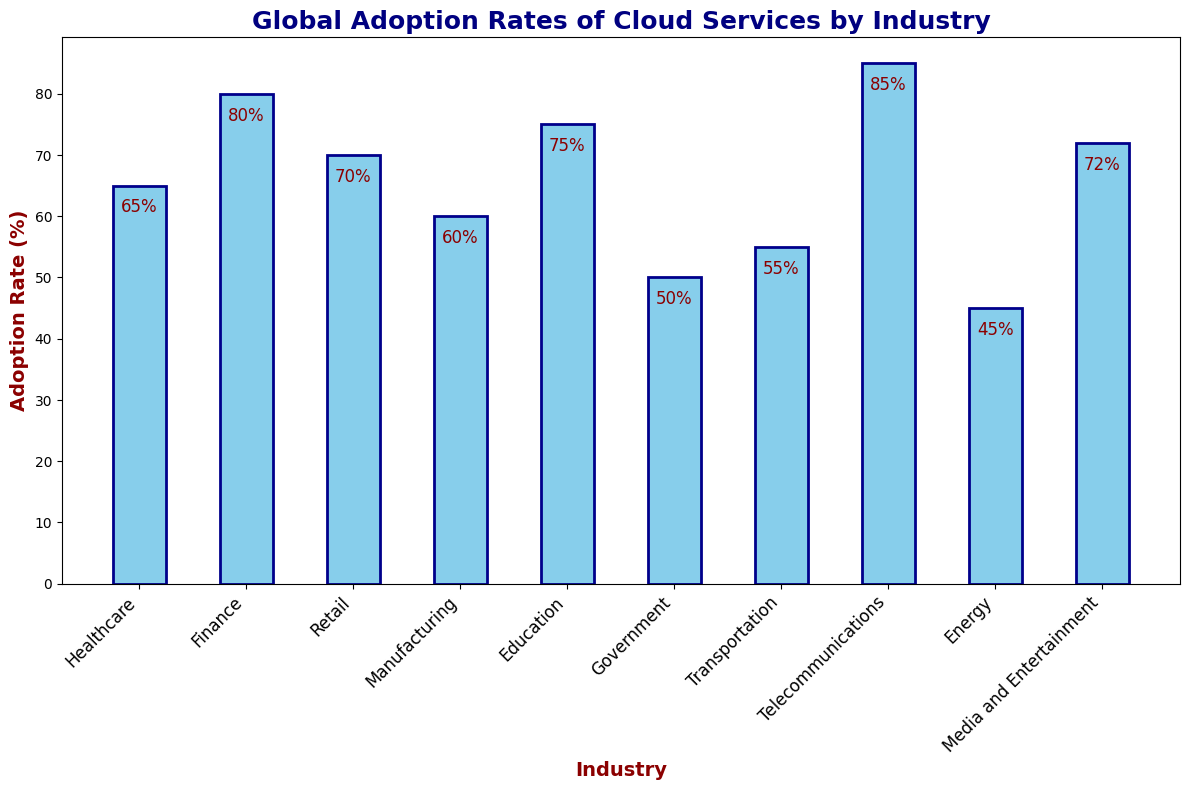Which industry has the highest adoption rate of cloud services? To find the industry with the highest adoption rate, look at the top of the tallest bar. The tallest bar represents the Telecommunications industry with an 85% adoption rate.
Answer: Telecommunications Which industry has a lower adoption rate, Government or Transportation? Compare the heights of the bars for Government and Transportation. Government has a 50% adoption rate, while Transportation has a 55% adoption rate. Therefore, the Government industry has a lower adoption rate.
Answer: Government What is the difference in cloud service adoption rates between Healthcare and Retail? The bar for Healthcare rests at 65% and the bar for Retail at 70%. Subtract the lower adoption rate (Healthcare) from the higher adoption rate (Retail): 70% - 65% = 5%.
Answer: 5% What is the combined adoption rate for Finance and Media and Entertainment? Find the adoption rates for Finance (80%) and Media and Entertainment (72%). Add these rates together: 80% + 72% = 152%.
Answer: 152% Which industry has the second-lowest adoption rate of cloud services? Identify the second shortest bar in the chart, which is the Energy industry with a 45% adoption rate (the shortest is Government with 50%).
Answer: Energy How many industries have an adoption rate above 70%? Count the bars with heights above the 70% mark: Finance (80%), Education (75%), Telecommunications (85%), and Media and Entertainment (72%). This makes a total of 4 industries.
Answer: 4 Which industries have adoption rates between 60% and 70% inclusive? Look for the bars within the 60%-70% range: Healthcare (65%) and Retail (70%).
Answer: Healthcare, Retail What is the average adoption rate of cloud services across all industries? Sum the adoption rates of all industries and divide by the number of industries: (65% + 80% + 70% + 60% + 75% + 50% + 55% + 85% + 45% + 72%) / 10 = 65.7%.
Answer: 65.7% How much higher is the adoption rate of Telecommunications compared to Government? Subtract the adoption rate of Government (50%) from that of Telecommunications (85%): 85% - 50% = 35%.
Answer: 35% What percentage of industries have an adoption rate below 60%? Count the industries with adoption rates below 60% (Government: 50%, Transportation: 55%, Energy: 45%). There are 3 industries out of 10 total, so calculate the percentage: (3/10) * 100 = 30%.
Answer: 30% 